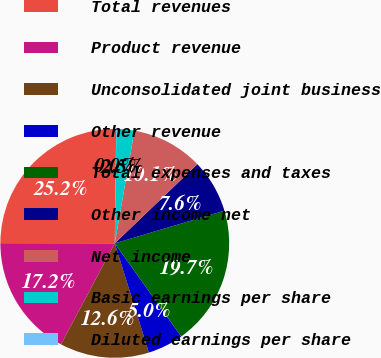Convert chart to OTSL. <chart><loc_0><loc_0><loc_500><loc_500><pie_chart><fcel>Total revenues<fcel>Product revenue<fcel>Unconsolidated joint business<fcel>Other revenue<fcel>Total expenses and taxes<fcel>Other income net<fcel>Net income<fcel>Basic earnings per share<fcel>Diluted earnings per share<nl><fcel>25.18%<fcel>17.24%<fcel>12.6%<fcel>5.05%<fcel>19.75%<fcel>7.56%<fcel>10.08%<fcel>2.53%<fcel>0.02%<nl></chart> 